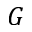Convert formula to latex. <formula><loc_0><loc_0><loc_500><loc_500>G</formula> 